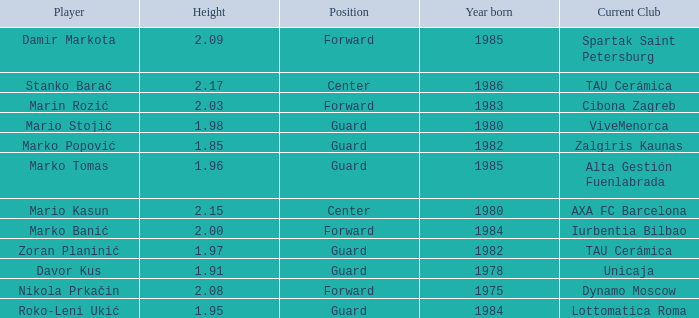What position does Mario Kasun play? Center. 